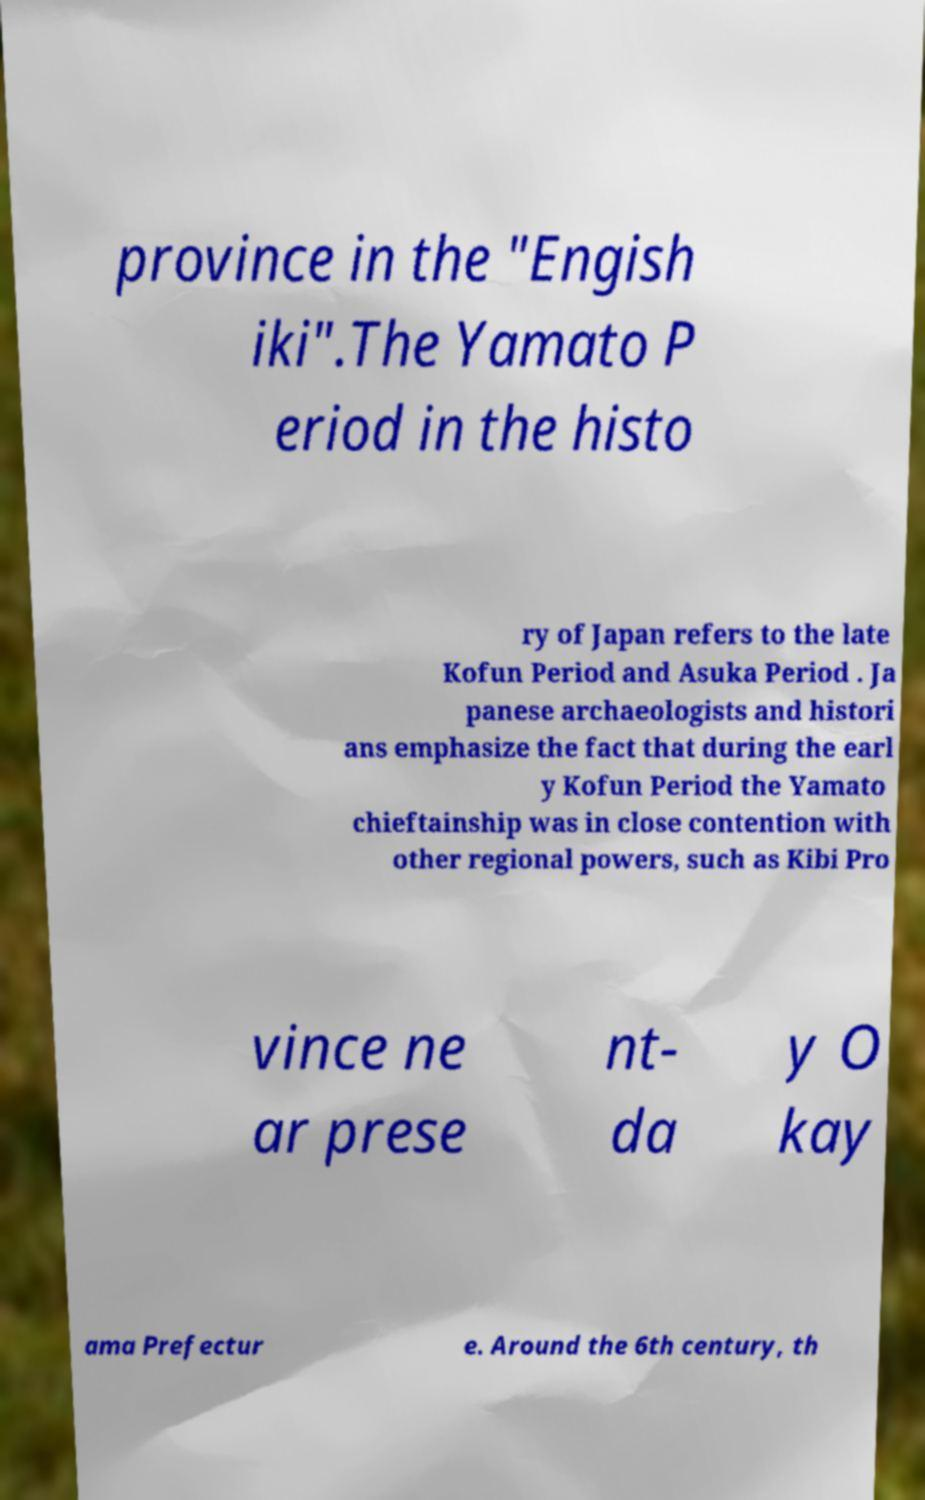Please identify and transcribe the text found in this image. province in the "Engish iki".The Yamato P eriod in the histo ry of Japan refers to the late Kofun Period and Asuka Period . Ja panese archaeologists and histori ans emphasize the fact that during the earl y Kofun Period the Yamato chieftainship was in close contention with other regional powers, such as Kibi Pro vince ne ar prese nt- da y O kay ama Prefectur e. Around the 6th century, th 